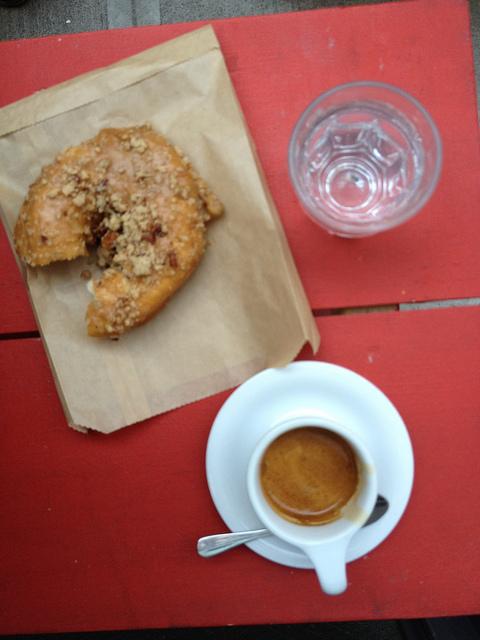Where is the doughnut placed?
Give a very brief answer. On napkin. What is in the mug?
Keep it brief. Coffee. What color table is the food on?
Quick response, please. Red. Has this food been eaten?
Give a very brief answer. Yes. How many donuts are picture?
Keep it brief. 1. What is on top of the donuts?
Give a very brief answer. Sugar. 